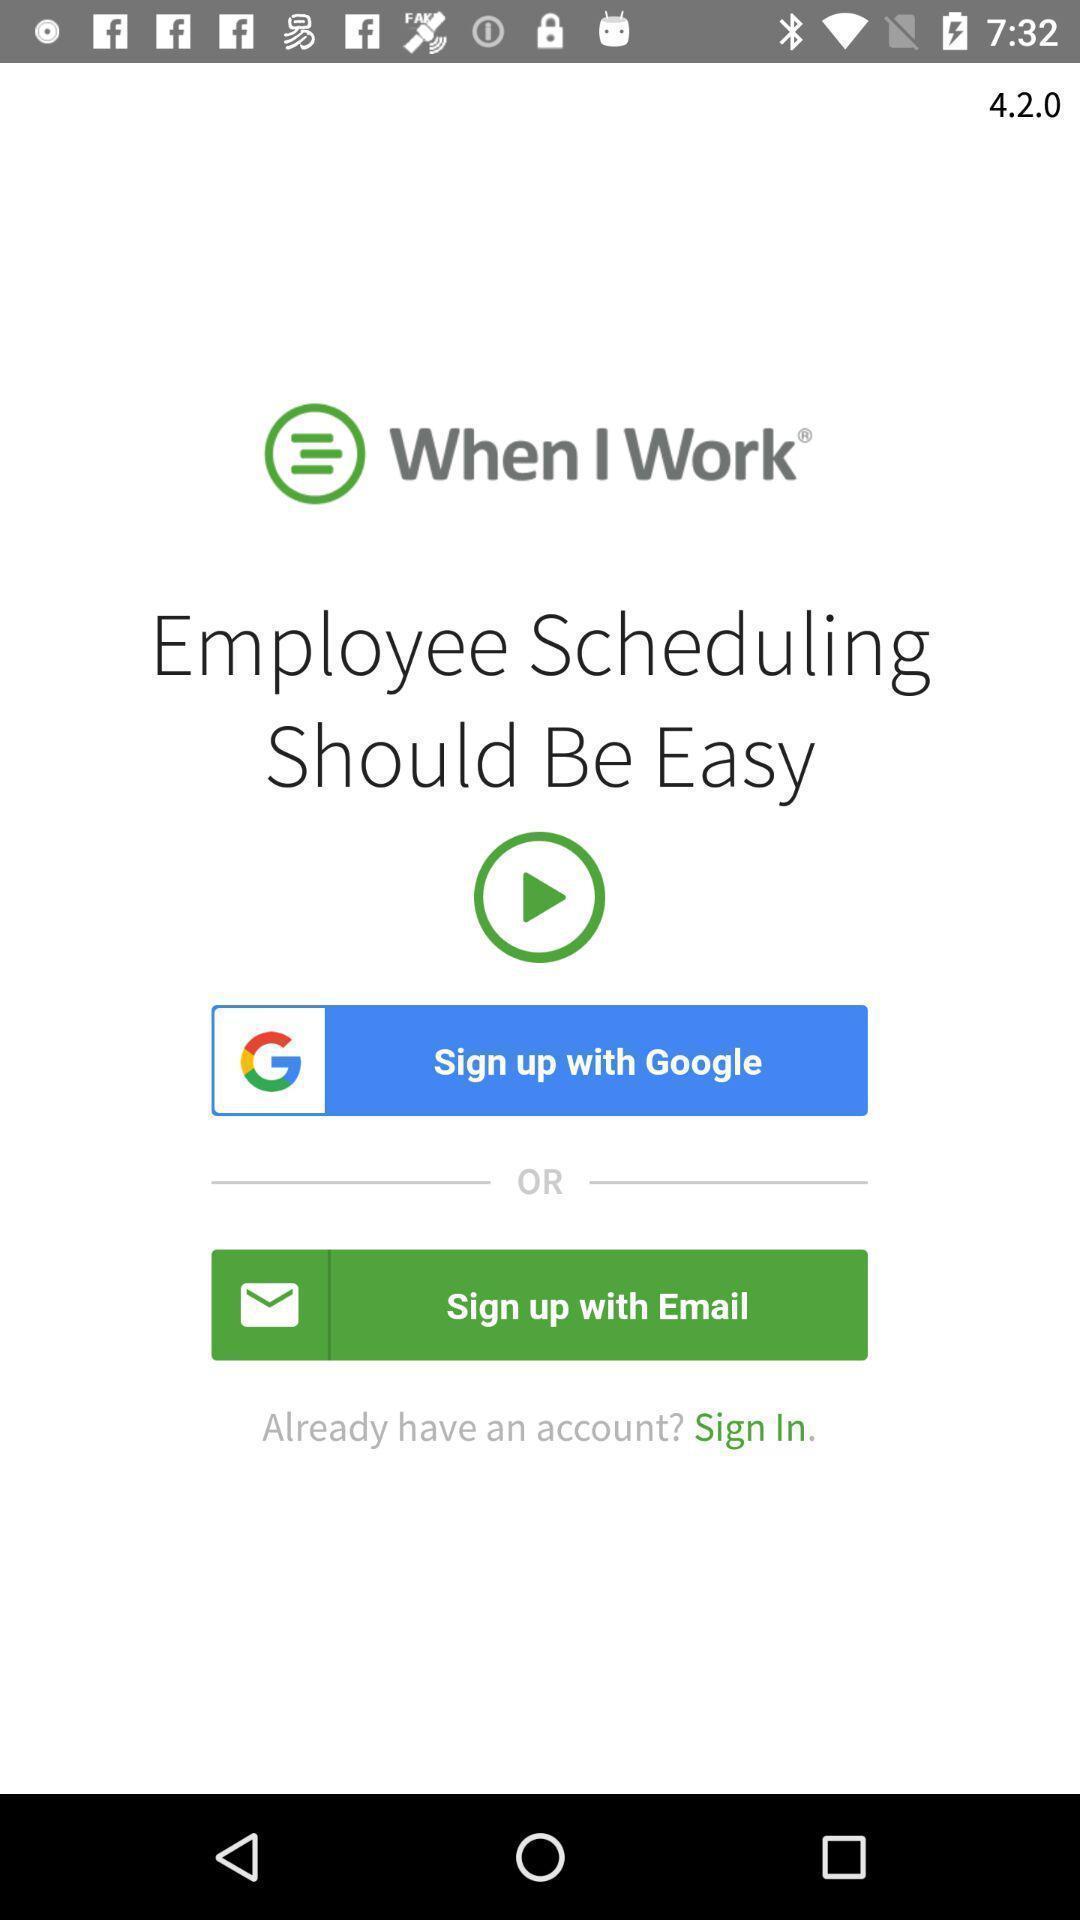Summarize the information in this screenshot. Welcome page of employee scheduling app. 